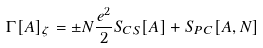Convert formula to latex. <formula><loc_0><loc_0><loc_500><loc_500>\Gamma [ A ] _ { \zeta } = \pm N \frac { e ^ { 2 } } { 2 } S _ { C S } [ A ] + S _ { P C } [ A , N ]</formula> 